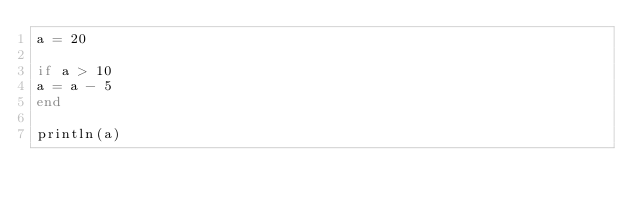Convert code to text. <code><loc_0><loc_0><loc_500><loc_500><_Julia_>a = 20

if a > 10
a = a - 5
end

println(a)
</code> 